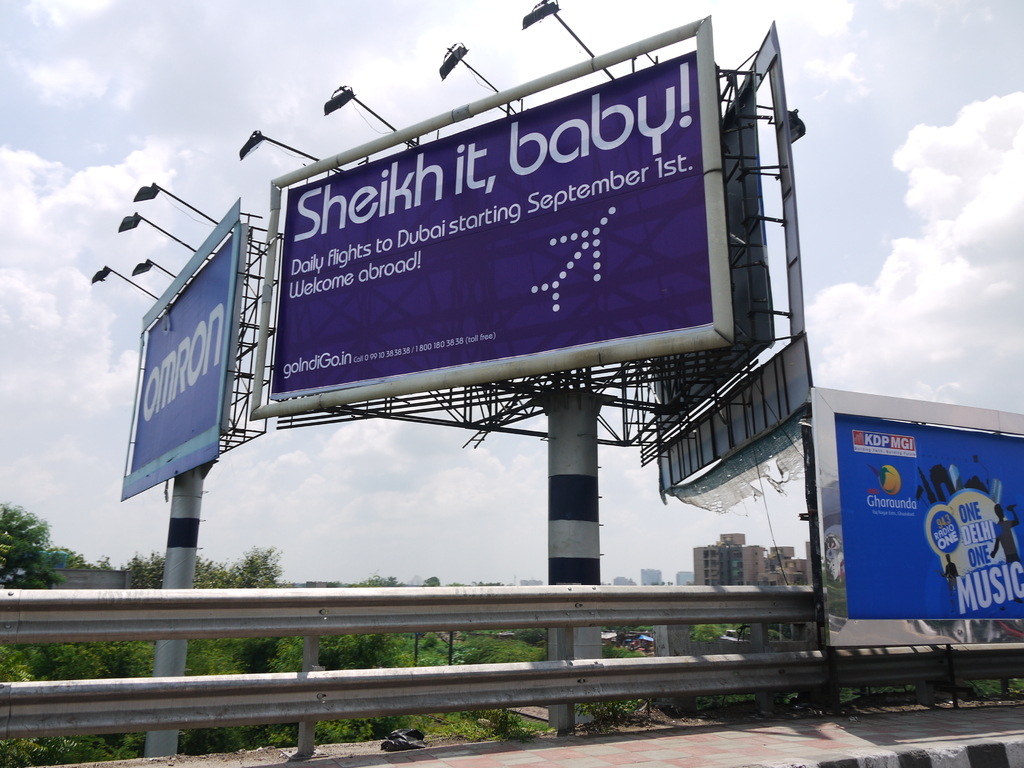What is the main advertising message of the billboard and how does the design support it? The main message of the billboard is to promote daily flights to Dubai starting September 1st, with an engaging and playful slogan 'Sheikh it, baby!'. The bold purple color scheme and large, readable text make it visually striking and memorable, enhancing the advertising impact. 